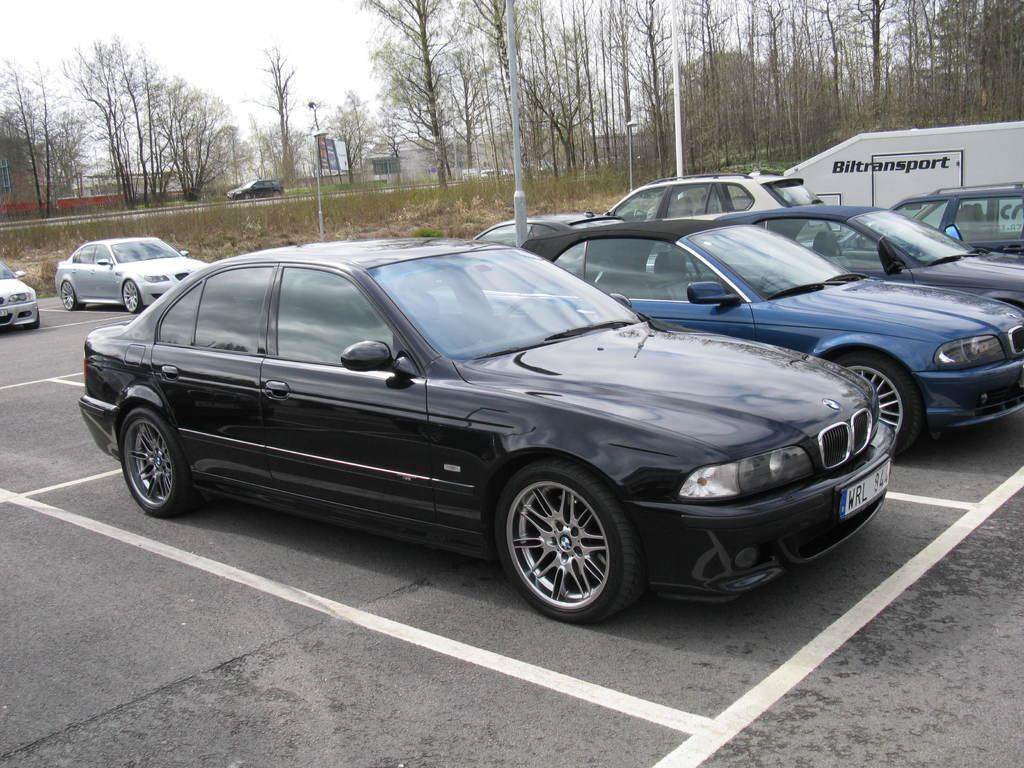What types of objects can be seen in the image? There are vehicles, poles, and lights in the image. What type of natural environment is visible in the image? There is grass and trees in the image. What is visible in the background of the image? The sky is visible in the background of the image. What color is the orange in the image? There is no orange present in the image. What force is being applied to the vehicles in the image? There is no indication of any force being applied to the vehicles in the image. 